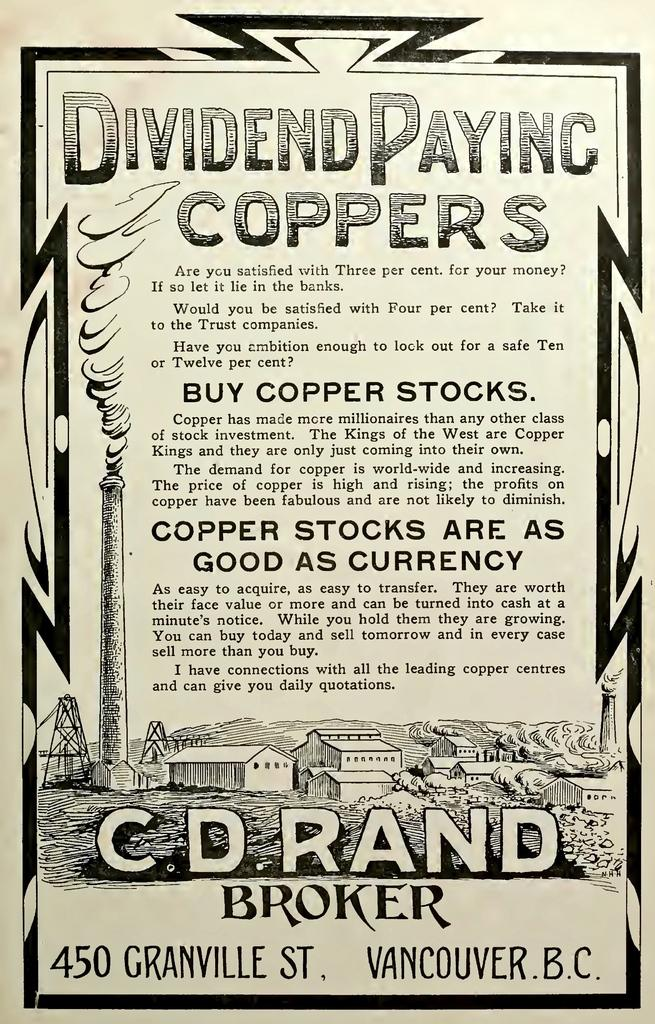<image>
Render a clear and concise summary of the photo. An old stock dividend paper for coppers from Vancouver, B.C. 